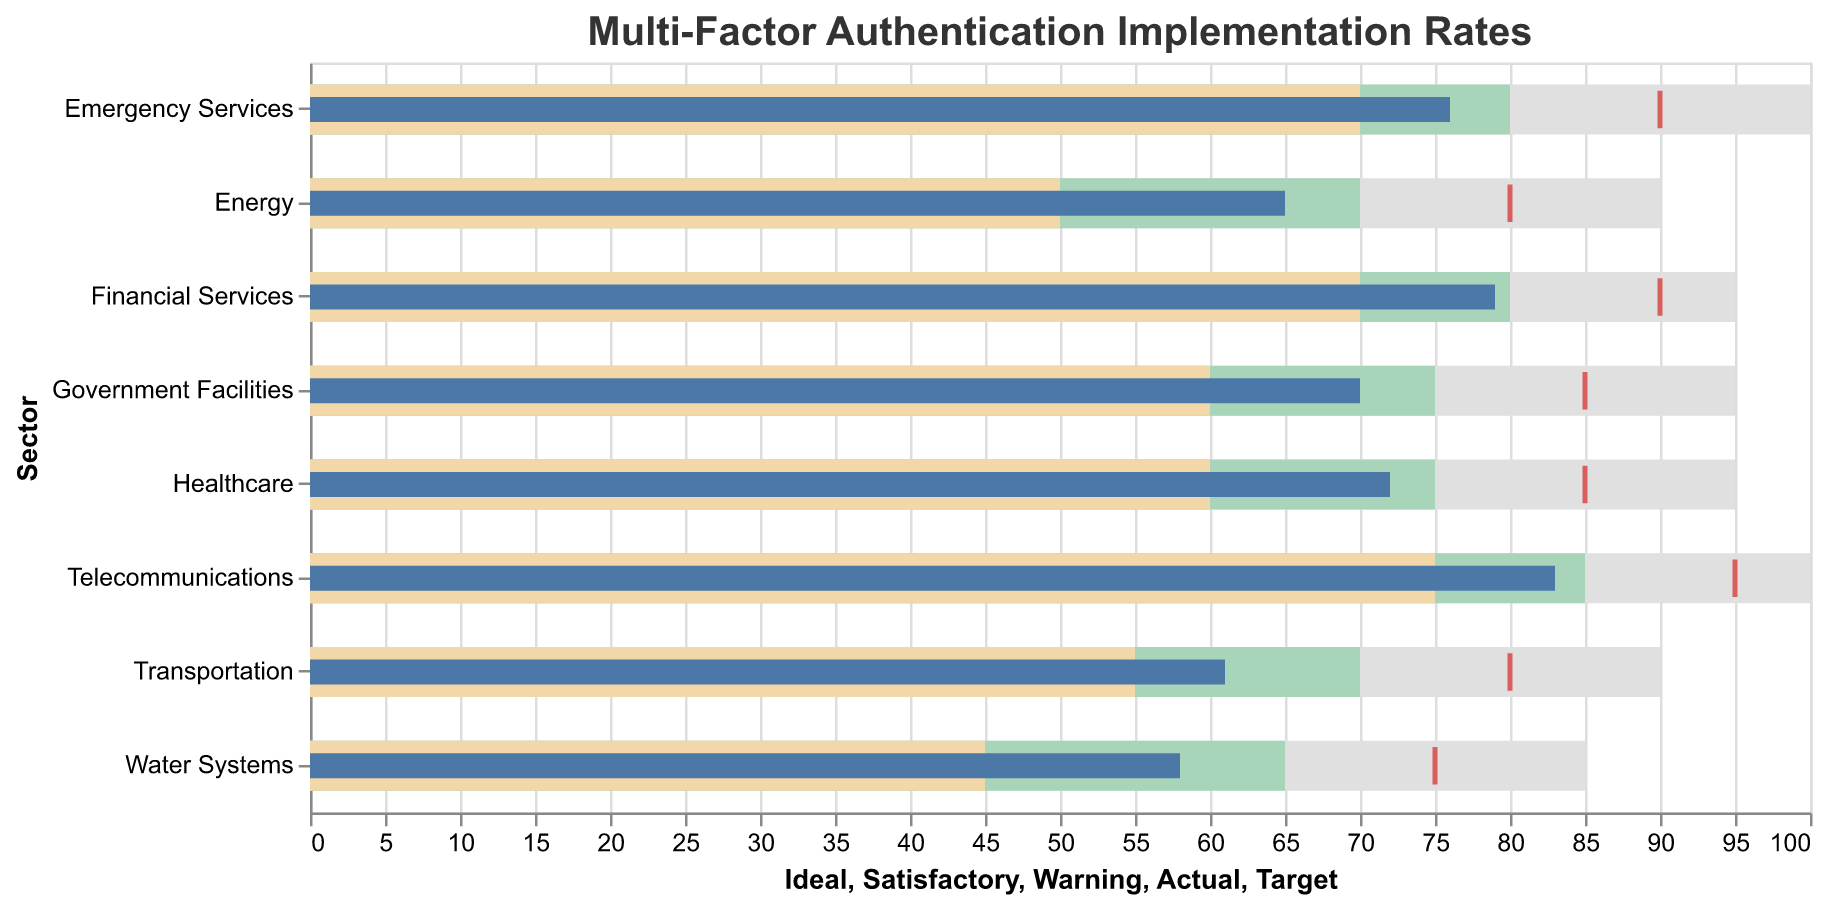What's the title of the figure? The title of the figure is displayed at the top of the chart in bold, larger text.
Answer: Multi-Factor Authentication Implementation Rates What is the actual implementation rate for the Energy sector? The actual implementation rate is shown by a blue bar for each sector. For the Energy sector, this blue bar corresponds to a value of 65.
Answer: 65 Which sector has the highest target rate? The highest target rate is indicated by a red tick mark on the horizontal axis. For the sector with the highest ideal rate, this tick mark is at 95, which corresponds to the Telecommunications sector.
Answer: Telecommunications How does the implementation rate for Healthcare compare to its satisfactory threshold? The satisfactory threshold is depicted by a green bar. The Healthcare sector's actual rate (blue bar) is measured against this green bar, indicating that the actual rate of 72 is below the satisfactory threshold of 75.
Answer: Below Which sectors have an actual implementation rate above 70%? By scanning the blue bars, we see that the sectors with an actual rate above 70% are Healthcare, Financial Services, Telecommunications, Government Facilities, and Emergency Services.
Answer: Healthcare, Financial Services, Telecommunications, Government Facilities, Emergency Services What is the difference between the actual rate and the target rate for the Financial Services sector? The Financial Services sector has an actual rate of 79 and a target rate of 90, as indicated by the blue bar and red tick mark respectively. The difference is calculated as 90 - 79 = 11.
Answer: 11 Which sector is closest to its target rate? The distance between the blue bar (actual rate) and the red tick mark (target rate) indicates closeness. Telecommunications sector has an actual rate of 83 and target rate of 95, with a distance of 12, which is the smallest gap when compared to others.
Answer: Telecommunications List the sectors that are in the warning range of multi-factor authentication implementation. The warning range is represented by the yellow bar. Sectors with actual rates falling within this bar are Energy and Water Systems.
Answer: Energy, Water Systems What is the average ideal rate across all sectors? The ideal rates across sectors are Energy (90), Healthcare (95), Water Systems (85), Transportation (90), Financial Services (95), Telecommunications (100), Government Facilities (95), and Emergency Services (100). The average is calculated as (90 + 95 + 85 + 90 + 95 + 100 + 95 + 100) / 8 = 93.75.
Answer: 93.75 Compare the implementation rates of Government Facilities and Emergency Services. Which sector has higher performance? The actual rate for Government Facilities is 70, and for Emergency Services, it is 76. The Emergency Services sector has a higher performance.
Answer: Emergency Services 